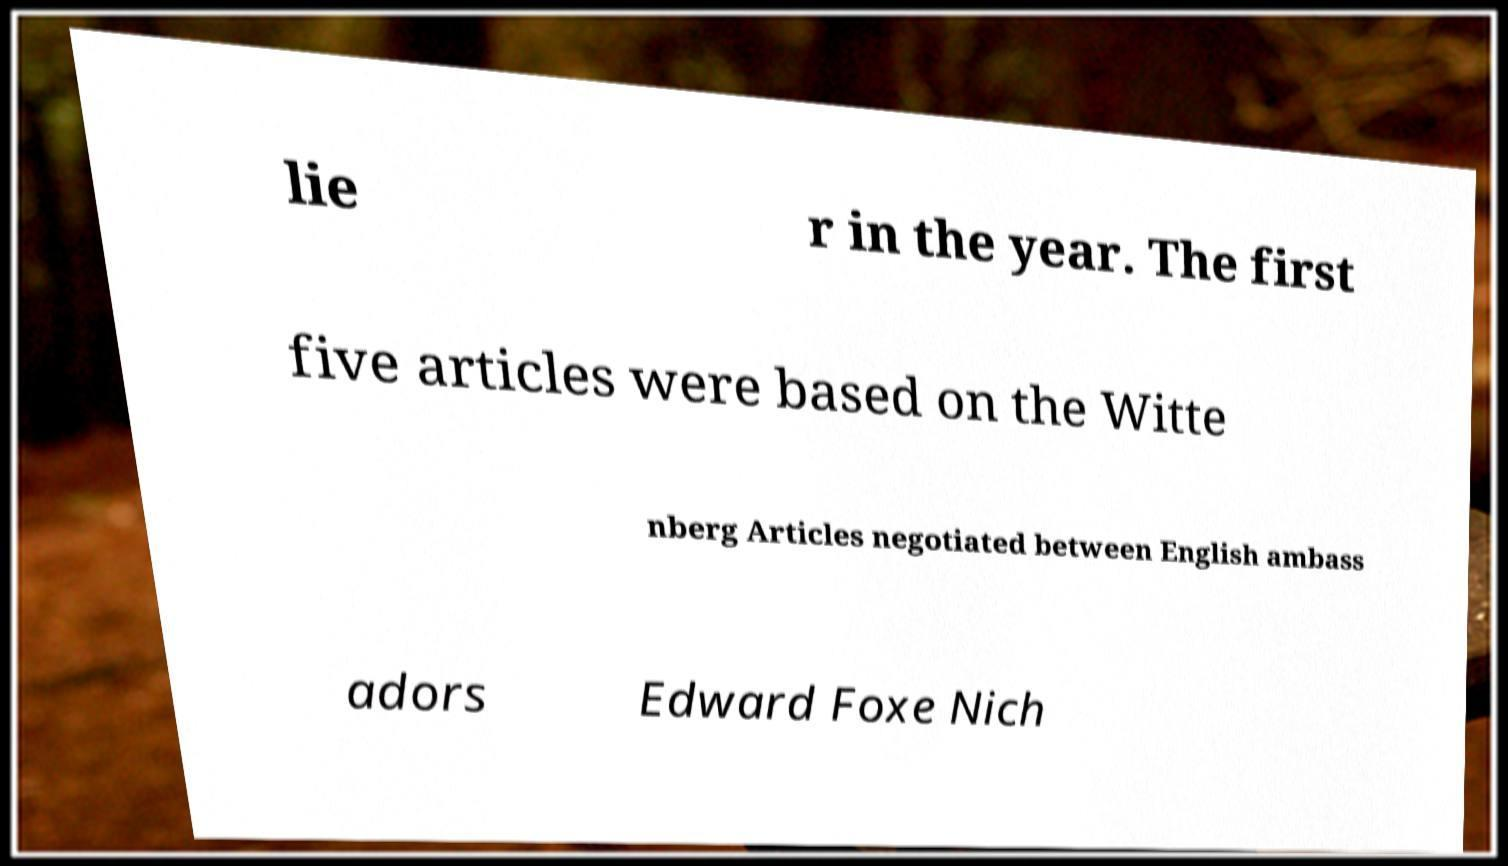What messages or text are displayed in this image? I need them in a readable, typed format. lie r in the year. The first five articles were based on the Witte nberg Articles negotiated between English ambass adors Edward Foxe Nich 